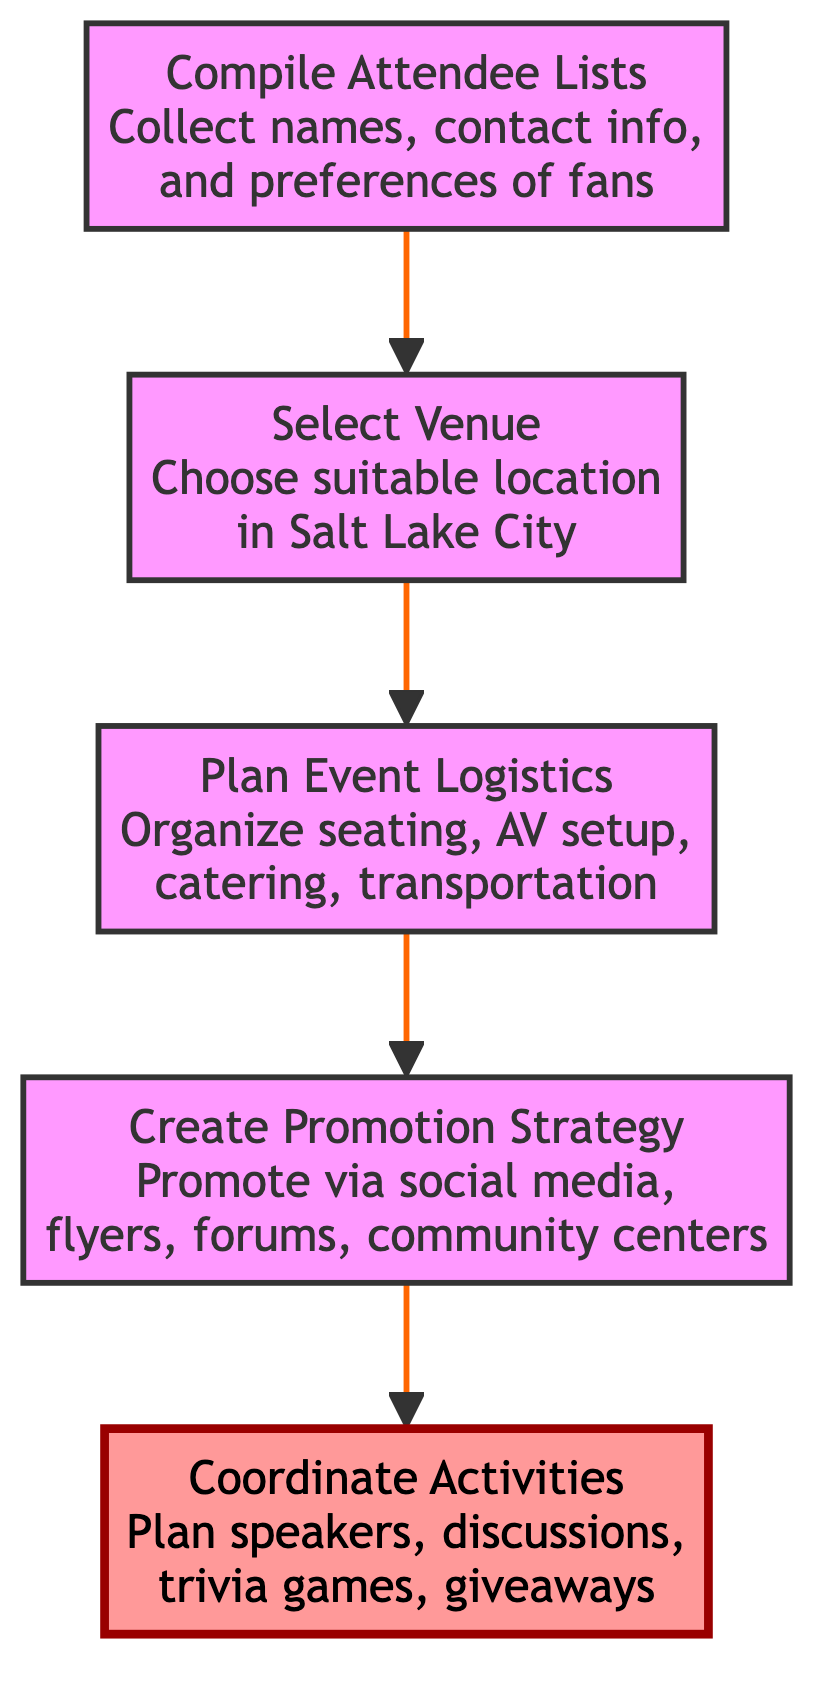What is the first step in organizing the fan meetup? The first step in the flowchart is labeled as "Compile Attendee Lists," which indicates that the process starts by collecting information about interested fans.
Answer: Compile Attendee Lists How many main steps are there in the fan meetup organization process? The diagram outlines five main steps from "Compile Attendee Lists" to "Coordinate Activities," indicating that there are a total of five steps in the organization process.
Answer: Five What comes immediately after planning event logistics? According to the flowchart, after "Plan Event Logistics," the next step is "Create Promotion Strategy," which outlines the strategy for promoting the event.
Answer: Create Promotion Strategy Which step focuses on promoting the meetup? The "Create Promotion Strategy" step specifically focuses on developing a strategy for promoting the meetup through various channels like social media and flyers.
Answer: Create Promotion Strategy What is the last activity detailed in the flowchart? The last step in the flow from the bottom to the top is "Coordinate Activities," indicating that planning and coordinating activities for the meetup is the final focus.
Answer: Coordinate Activities How does the "Select Venue" step relate to other steps? The "Select Venue" step is a transitional step following "Compile Attendee Lists" and preceding "Plan Event Logistics," showing that venue selection is essential for organizing logistics for the event.
Answer: It is transitional What type of activity is included during the meetup? The "Coordinate Activities" stage details various activities that can happen during the meetup, such as guest speakers, fan discussions, trivia games, and merchandise giveaways.
Answer: Trivia games How does this flowchart type help in organizing events? The flowchart type visually organizes the steps required for organizing the fan meetup from bottom to top, making the sequence of tasks clear and straightforward to follow for effective event planning.
Answer: It visualizes steps 